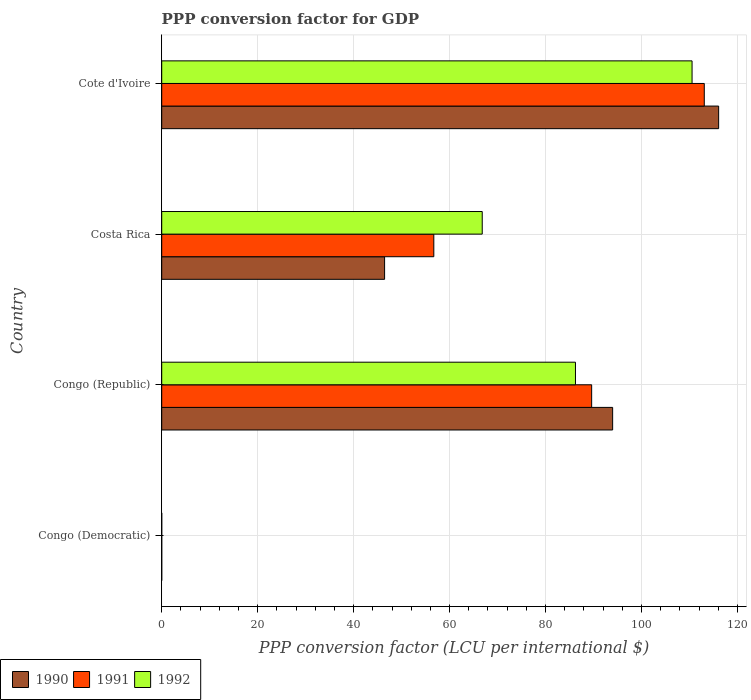How many groups of bars are there?
Provide a succinct answer. 4. How many bars are there on the 4th tick from the top?
Your answer should be compact. 3. What is the label of the 1st group of bars from the top?
Your answer should be compact. Cote d'Ivoire. In how many cases, is the number of bars for a given country not equal to the number of legend labels?
Provide a short and direct response. 0. What is the PPP conversion factor for GDP in 1990 in Congo (Republic)?
Provide a succinct answer. 93.98. Across all countries, what is the maximum PPP conversion factor for GDP in 1990?
Make the answer very short. 116.07. Across all countries, what is the minimum PPP conversion factor for GDP in 1990?
Your answer should be very brief. 7.8159328794866e-10. In which country was the PPP conversion factor for GDP in 1990 maximum?
Provide a succinct answer. Cote d'Ivoire. In which country was the PPP conversion factor for GDP in 1992 minimum?
Give a very brief answer. Congo (Democratic). What is the total PPP conversion factor for GDP in 1991 in the graph?
Give a very brief answer. 259.39. What is the difference between the PPP conversion factor for GDP in 1990 in Congo (Republic) and that in Costa Rica?
Your answer should be compact. 47.53. What is the difference between the PPP conversion factor for GDP in 1991 in Cote d'Ivoire and the PPP conversion factor for GDP in 1992 in Costa Rica?
Provide a succinct answer. 46.28. What is the average PPP conversion factor for GDP in 1992 per country?
Make the answer very short. 65.89. What is the difference between the PPP conversion factor for GDP in 1990 and PPP conversion factor for GDP in 1991 in Congo (Democratic)?
Provide a short and direct response. -1.7663227395208438e-8. What is the ratio of the PPP conversion factor for GDP in 1990 in Costa Rica to that in Cote d'Ivoire?
Offer a very short reply. 0.4. Is the PPP conversion factor for GDP in 1990 in Congo (Democratic) less than that in Congo (Republic)?
Your answer should be compact. Yes. Is the difference between the PPP conversion factor for GDP in 1990 in Congo (Democratic) and Cote d'Ivoire greater than the difference between the PPP conversion factor for GDP in 1991 in Congo (Democratic) and Cote d'Ivoire?
Your answer should be very brief. No. What is the difference between the highest and the second highest PPP conversion factor for GDP in 1990?
Provide a succinct answer. 22.09. What is the difference between the highest and the lowest PPP conversion factor for GDP in 1990?
Make the answer very short. 116.07. Is the sum of the PPP conversion factor for GDP in 1990 in Congo (Republic) and Costa Rica greater than the maximum PPP conversion factor for GDP in 1992 across all countries?
Your response must be concise. Yes. What does the 2nd bar from the top in Costa Rica represents?
Give a very brief answer. 1991. What does the 2nd bar from the bottom in Congo (Democratic) represents?
Your response must be concise. 1991. How many bars are there?
Offer a terse response. 12. Are all the bars in the graph horizontal?
Make the answer very short. Yes. How many countries are there in the graph?
Offer a terse response. 4. What is the difference between two consecutive major ticks on the X-axis?
Your answer should be compact. 20. Does the graph contain any zero values?
Offer a terse response. No. Does the graph contain grids?
Your answer should be compact. Yes. Where does the legend appear in the graph?
Your answer should be compact. Bottom left. How many legend labels are there?
Keep it short and to the point. 3. What is the title of the graph?
Keep it short and to the point. PPP conversion factor for GDP. Does "1962" appear as one of the legend labels in the graph?
Ensure brevity in your answer.  No. What is the label or title of the X-axis?
Your answer should be very brief. PPP conversion factor (LCU per international $). What is the label or title of the Y-axis?
Your answer should be compact. Country. What is the PPP conversion factor (LCU per international $) of 1990 in Congo (Democratic)?
Provide a succinct answer. 7.8159328794866e-10. What is the PPP conversion factor (LCU per international $) in 1991 in Congo (Democratic)?
Your answer should be very brief. 1.84448206831571e-8. What is the PPP conversion factor (LCU per international $) of 1992 in Congo (Democratic)?
Ensure brevity in your answer.  7.132896045372209e-7. What is the PPP conversion factor (LCU per international $) of 1990 in Congo (Republic)?
Give a very brief answer. 93.98. What is the PPP conversion factor (LCU per international $) of 1991 in Congo (Republic)?
Give a very brief answer. 89.6. What is the PPP conversion factor (LCU per international $) in 1992 in Congo (Republic)?
Your answer should be compact. 86.23. What is the PPP conversion factor (LCU per international $) in 1990 in Costa Rica?
Give a very brief answer. 46.45. What is the PPP conversion factor (LCU per international $) in 1991 in Costa Rica?
Your answer should be very brief. 56.71. What is the PPP conversion factor (LCU per international $) of 1992 in Costa Rica?
Ensure brevity in your answer.  66.8. What is the PPP conversion factor (LCU per international $) of 1990 in Cote d'Ivoire?
Make the answer very short. 116.07. What is the PPP conversion factor (LCU per international $) in 1991 in Cote d'Ivoire?
Your answer should be very brief. 113.08. What is the PPP conversion factor (LCU per international $) in 1992 in Cote d'Ivoire?
Offer a terse response. 110.53. Across all countries, what is the maximum PPP conversion factor (LCU per international $) in 1990?
Provide a succinct answer. 116.07. Across all countries, what is the maximum PPP conversion factor (LCU per international $) in 1991?
Keep it short and to the point. 113.08. Across all countries, what is the maximum PPP conversion factor (LCU per international $) of 1992?
Your answer should be very brief. 110.53. Across all countries, what is the minimum PPP conversion factor (LCU per international $) in 1990?
Provide a short and direct response. 7.8159328794866e-10. Across all countries, what is the minimum PPP conversion factor (LCU per international $) in 1991?
Make the answer very short. 1.84448206831571e-8. Across all countries, what is the minimum PPP conversion factor (LCU per international $) of 1992?
Offer a very short reply. 7.132896045372209e-7. What is the total PPP conversion factor (LCU per international $) of 1990 in the graph?
Make the answer very short. 256.5. What is the total PPP conversion factor (LCU per international $) in 1991 in the graph?
Offer a very short reply. 259.39. What is the total PPP conversion factor (LCU per international $) of 1992 in the graph?
Your answer should be very brief. 263.56. What is the difference between the PPP conversion factor (LCU per international $) of 1990 in Congo (Democratic) and that in Congo (Republic)?
Provide a succinct answer. -93.98. What is the difference between the PPP conversion factor (LCU per international $) of 1991 in Congo (Democratic) and that in Congo (Republic)?
Provide a short and direct response. -89.6. What is the difference between the PPP conversion factor (LCU per international $) in 1992 in Congo (Democratic) and that in Congo (Republic)?
Give a very brief answer. -86.23. What is the difference between the PPP conversion factor (LCU per international $) of 1990 in Congo (Democratic) and that in Costa Rica?
Offer a very short reply. -46.45. What is the difference between the PPP conversion factor (LCU per international $) in 1991 in Congo (Democratic) and that in Costa Rica?
Offer a terse response. -56.71. What is the difference between the PPP conversion factor (LCU per international $) of 1992 in Congo (Democratic) and that in Costa Rica?
Your response must be concise. -66.8. What is the difference between the PPP conversion factor (LCU per international $) in 1990 in Congo (Democratic) and that in Cote d'Ivoire?
Your answer should be compact. -116.07. What is the difference between the PPP conversion factor (LCU per international $) in 1991 in Congo (Democratic) and that in Cote d'Ivoire?
Your answer should be very brief. -113.08. What is the difference between the PPP conversion factor (LCU per international $) of 1992 in Congo (Democratic) and that in Cote d'Ivoire?
Make the answer very short. -110.53. What is the difference between the PPP conversion factor (LCU per international $) of 1990 in Congo (Republic) and that in Costa Rica?
Make the answer very short. 47.53. What is the difference between the PPP conversion factor (LCU per international $) of 1991 in Congo (Republic) and that in Costa Rica?
Offer a terse response. 32.9. What is the difference between the PPP conversion factor (LCU per international $) in 1992 in Congo (Republic) and that in Costa Rica?
Your answer should be very brief. 19.43. What is the difference between the PPP conversion factor (LCU per international $) in 1990 in Congo (Republic) and that in Cote d'Ivoire?
Make the answer very short. -22.09. What is the difference between the PPP conversion factor (LCU per international $) of 1991 in Congo (Republic) and that in Cote d'Ivoire?
Offer a very short reply. -23.47. What is the difference between the PPP conversion factor (LCU per international $) of 1992 in Congo (Republic) and that in Cote d'Ivoire?
Provide a short and direct response. -24.3. What is the difference between the PPP conversion factor (LCU per international $) in 1990 in Costa Rica and that in Cote d'Ivoire?
Ensure brevity in your answer.  -69.62. What is the difference between the PPP conversion factor (LCU per international $) in 1991 in Costa Rica and that in Cote d'Ivoire?
Your answer should be compact. -56.37. What is the difference between the PPP conversion factor (LCU per international $) of 1992 in Costa Rica and that in Cote d'Ivoire?
Ensure brevity in your answer.  -43.73. What is the difference between the PPP conversion factor (LCU per international $) of 1990 in Congo (Democratic) and the PPP conversion factor (LCU per international $) of 1991 in Congo (Republic)?
Provide a short and direct response. -89.6. What is the difference between the PPP conversion factor (LCU per international $) in 1990 in Congo (Democratic) and the PPP conversion factor (LCU per international $) in 1992 in Congo (Republic)?
Offer a very short reply. -86.23. What is the difference between the PPP conversion factor (LCU per international $) of 1991 in Congo (Democratic) and the PPP conversion factor (LCU per international $) of 1992 in Congo (Republic)?
Your answer should be compact. -86.23. What is the difference between the PPP conversion factor (LCU per international $) in 1990 in Congo (Democratic) and the PPP conversion factor (LCU per international $) in 1991 in Costa Rica?
Make the answer very short. -56.71. What is the difference between the PPP conversion factor (LCU per international $) in 1990 in Congo (Democratic) and the PPP conversion factor (LCU per international $) in 1992 in Costa Rica?
Offer a terse response. -66.8. What is the difference between the PPP conversion factor (LCU per international $) of 1991 in Congo (Democratic) and the PPP conversion factor (LCU per international $) of 1992 in Costa Rica?
Ensure brevity in your answer.  -66.8. What is the difference between the PPP conversion factor (LCU per international $) in 1990 in Congo (Democratic) and the PPP conversion factor (LCU per international $) in 1991 in Cote d'Ivoire?
Give a very brief answer. -113.08. What is the difference between the PPP conversion factor (LCU per international $) of 1990 in Congo (Democratic) and the PPP conversion factor (LCU per international $) of 1992 in Cote d'Ivoire?
Offer a very short reply. -110.53. What is the difference between the PPP conversion factor (LCU per international $) in 1991 in Congo (Democratic) and the PPP conversion factor (LCU per international $) in 1992 in Cote d'Ivoire?
Provide a succinct answer. -110.53. What is the difference between the PPP conversion factor (LCU per international $) of 1990 in Congo (Republic) and the PPP conversion factor (LCU per international $) of 1991 in Costa Rica?
Your response must be concise. 37.27. What is the difference between the PPP conversion factor (LCU per international $) in 1990 in Congo (Republic) and the PPP conversion factor (LCU per international $) in 1992 in Costa Rica?
Make the answer very short. 27.18. What is the difference between the PPP conversion factor (LCU per international $) in 1991 in Congo (Republic) and the PPP conversion factor (LCU per international $) in 1992 in Costa Rica?
Keep it short and to the point. 22.8. What is the difference between the PPP conversion factor (LCU per international $) in 1990 in Congo (Republic) and the PPP conversion factor (LCU per international $) in 1991 in Cote d'Ivoire?
Keep it short and to the point. -19.1. What is the difference between the PPP conversion factor (LCU per international $) in 1990 in Congo (Republic) and the PPP conversion factor (LCU per international $) in 1992 in Cote d'Ivoire?
Give a very brief answer. -16.55. What is the difference between the PPP conversion factor (LCU per international $) in 1991 in Congo (Republic) and the PPP conversion factor (LCU per international $) in 1992 in Cote d'Ivoire?
Your response must be concise. -20.93. What is the difference between the PPP conversion factor (LCU per international $) in 1990 in Costa Rica and the PPP conversion factor (LCU per international $) in 1991 in Cote d'Ivoire?
Your answer should be compact. -66.63. What is the difference between the PPP conversion factor (LCU per international $) in 1990 in Costa Rica and the PPP conversion factor (LCU per international $) in 1992 in Cote d'Ivoire?
Offer a terse response. -64.08. What is the difference between the PPP conversion factor (LCU per international $) of 1991 in Costa Rica and the PPP conversion factor (LCU per international $) of 1992 in Cote d'Ivoire?
Make the answer very short. -53.82. What is the average PPP conversion factor (LCU per international $) in 1990 per country?
Your response must be concise. 64.13. What is the average PPP conversion factor (LCU per international $) of 1991 per country?
Your answer should be compact. 64.85. What is the average PPP conversion factor (LCU per international $) of 1992 per country?
Provide a succinct answer. 65.89. What is the difference between the PPP conversion factor (LCU per international $) in 1990 and PPP conversion factor (LCU per international $) in 1991 in Congo (Republic)?
Provide a short and direct response. 4.37. What is the difference between the PPP conversion factor (LCU per international $) in 1990 and PPP conversion factor (LCU per international $) in 1992 in Congo (Republic)?
Your answer should be very brief. 7.75. What is the difference between the PPP conversion factor (LCU per international $) of 1991 and PPP conversion factor (LCU per international $) of 1992 in Congo (Republic)?
Provide a short and direct response. 3.37. What is the difference between the PPP conversion factor (LCU per international $) in 1990 and PPP conversion factor (LCU per international $) in 1991 in Costa Rica?
Offer a terse response. -10.26. What is the difference between the PPP conversion factor (LCU per international $) in 1990 and PPP conversion factor (LCU per international $) in 1992 in Costa Rica?
Keep it short and to the point. -20.35. What is the difference between the PPP conversion factor (LCU per international $) in 1991 and PPP conversion factor (LCU per international $) in 1992 in Costa Rica?
Provide a short and direct response. -10.09. What is the difference between the PPP conversion factor (LCU per international $) in 1990 and PPP conversion factor (LCU per international $) in 1991 in Cote d'Ivoire?
Offer a terse response. 2.99. What is the difference between the PPP conversion factor (LCU per international $) of 1990 and PPP conversion factor (LCU per international $) of 1992 in Cote d'Ivoire?
Provide a succinct answer. 5.54. What is the difference between the PPP conversion factor (LCU per international $) in 1991 and PPP conversion factor (LCU per international $) in 1992 in Cote d'Ivoire?
Provide a short and direct response. 2.55. What is the ratio of the PPP conversion factor (LCU per international $) of 1990 in Congo (Democratic) to that in Congo (Republic)?
Provide a succinct answer. 0. What is the ratio of the PPP conversion factor (LCU per international $) in 1992 in Congo (Democratic) to that in Congo (Republic)?
Your answer should be compact. 0. What is the ratio of the PPP conversion factor (LCU per international $) in 1991 in Congo (Democratic) to that in Costa Rica?
Make the answer very short. 0. What is the ratio of the PPP conversion factor (LCU per international $) in 1992 in Congo (Democratic) to that in Costa Rica?
Give a very brief answer. 0. What is the ratio of the PPP conversion factor (LCU per international $) of 1991 in Congo (Democratic) to that in Cote d'Ivoire?
Offer a very short reply. 0. What is the ratio of the PPP conversion factor (LCU per international $) of 1992 in Congo (Democratic) to that in Cote d'Ivoire?
Your answer should be compact. 0. What is the ratio of the PPP conversion factor (LCU per international $) in 1990 in Congo (Republic) to that in Costa Rica?
Provide a succinct answer. 2.02. What is the ratio of the PPP conversion factor (LCU per international $) in 1991 in Congo (Republic) to that in Costa Rica?
Provide a succinct answer. 1.58. What is the ratio of the PPP conversion factor (LCU per international $) of 1992 in Congo (Republic) to that in Costa Rica?
Give a very brief answer. 1.29. What is the ratio of the PPP conversion factor (LCU per international $) of 1990 in Congo (Republic) to that in Cote d'Ivoire?
Your answer should be very brief. 0.81. What is the ratio of the PPP conversion factor (LCU per international $) in 1991 in Congo (Republic) to that in Cote d'Ivoire?
Your response must be concise. 0.79. What is the ratio of the PPP conversion factor (LCU per international $) of 1992 in Congo (Republic) to that in Cote d'Ivoire?
Ensure brevity in your answer.  0.78. What is the ratio of the PPP conversion factor (LCU per international $) of 1990 in Costa Rica to that in Cote d'Ivoire?
Provide a succinct answer. 0.4. What is the ratio of the PPP conversion factor (LCU per international $) in 1991 in Costa Rica to that in Cote d'Ivoire?
Make the answer very short. 0.5. What is the ratio of the PPP conversion factor (LCU per international $) of 1992 in Costa Rica to that in Cote d'Ivoire?
Offer a very short reply. 0.6. What is the difference between the highest and the second highest PPP conversion factor (LCU per international $) in 1990?
Make the answer very short. 22.09. What is the difference between the highest and the second highest PPP conversion factor (LCU per international $) of 1991?
Provide a short and direct response. 23.47. What is the difference between the highest and the second highest PPP conversion factor (LCU per international $) of 1992?
Provide a succinct answer. 24.3. What is the difference between the highest and the lowest PPP conversion factor (LCU per international $) of 1990?
Your response must be concise. 116.07. What is the difference between the highest and the lowest PPP conversion factor (LCU per international $) of 1991?
Provide a succinct answer. 113.08. What is the difference between the highest and the lowest PPP conversion factor (LCU per international $) in 1992?
Provide a succinct answer. 110.53. 